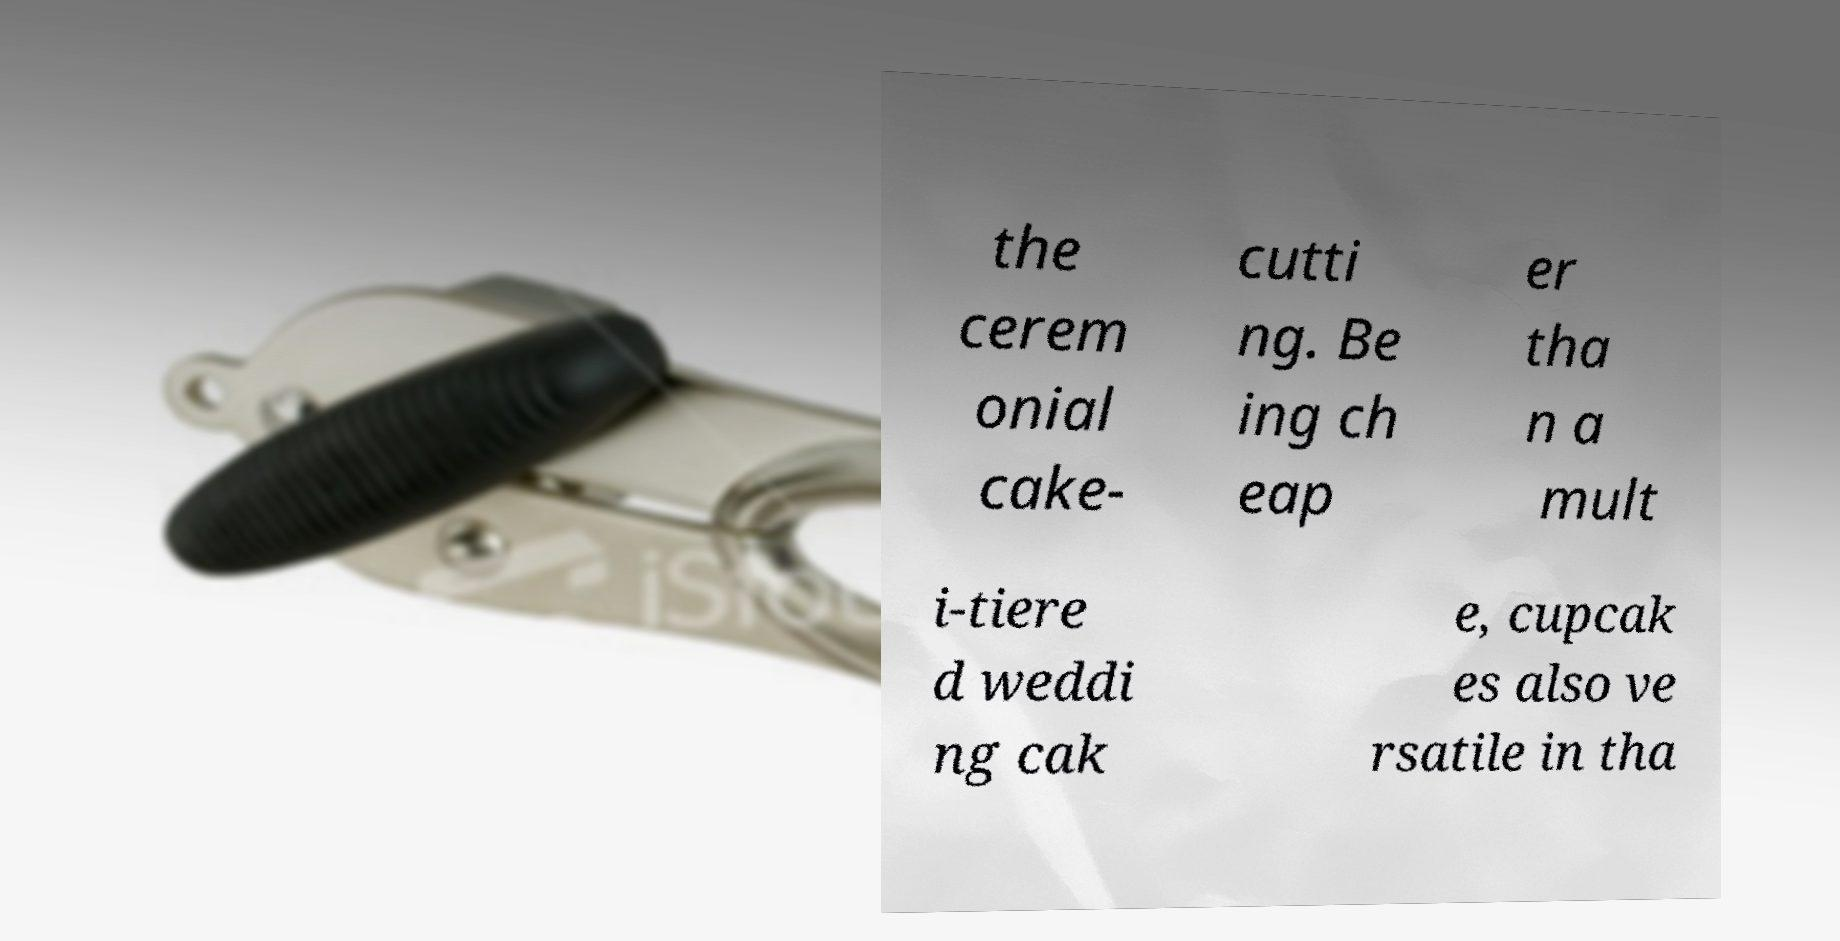What messages or text are displayed in this image? I need them in a readable, typed format. the cerem onial cake- cutti ng. Be ing ch eap er tha n a mult i-tiere d weddi ng cak e, cupcak es also ve rsatile in tha 